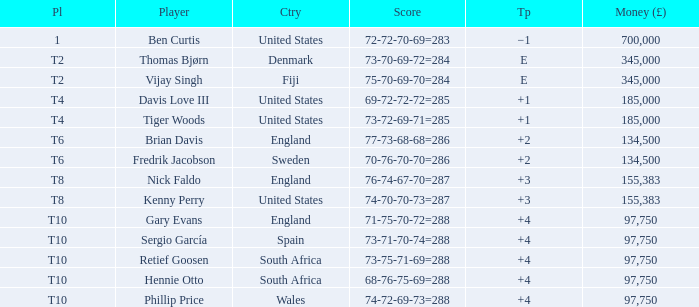What is the Place of Davis Love III with a To Par of +1? T4. 